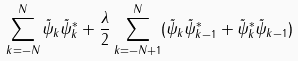<formula> <loc_0><loc_0><loc_500><loc_500>\sum _ { k = - N } ^ { N } \tilde { \psi } _ { k } \tilde { \psi } ^ { * } _ { k } + \frac { \lambda } { 2 } \sum _ { k = - N + 1 } ^ { N } ( \tilde { \psi } _ { k } \tilde { \psi } ^ { * } _ { k - 1 } + \tilde { \psi } _ { k } ^ { * } \tilde { \psi } _ { k - 1 } )</formula> 